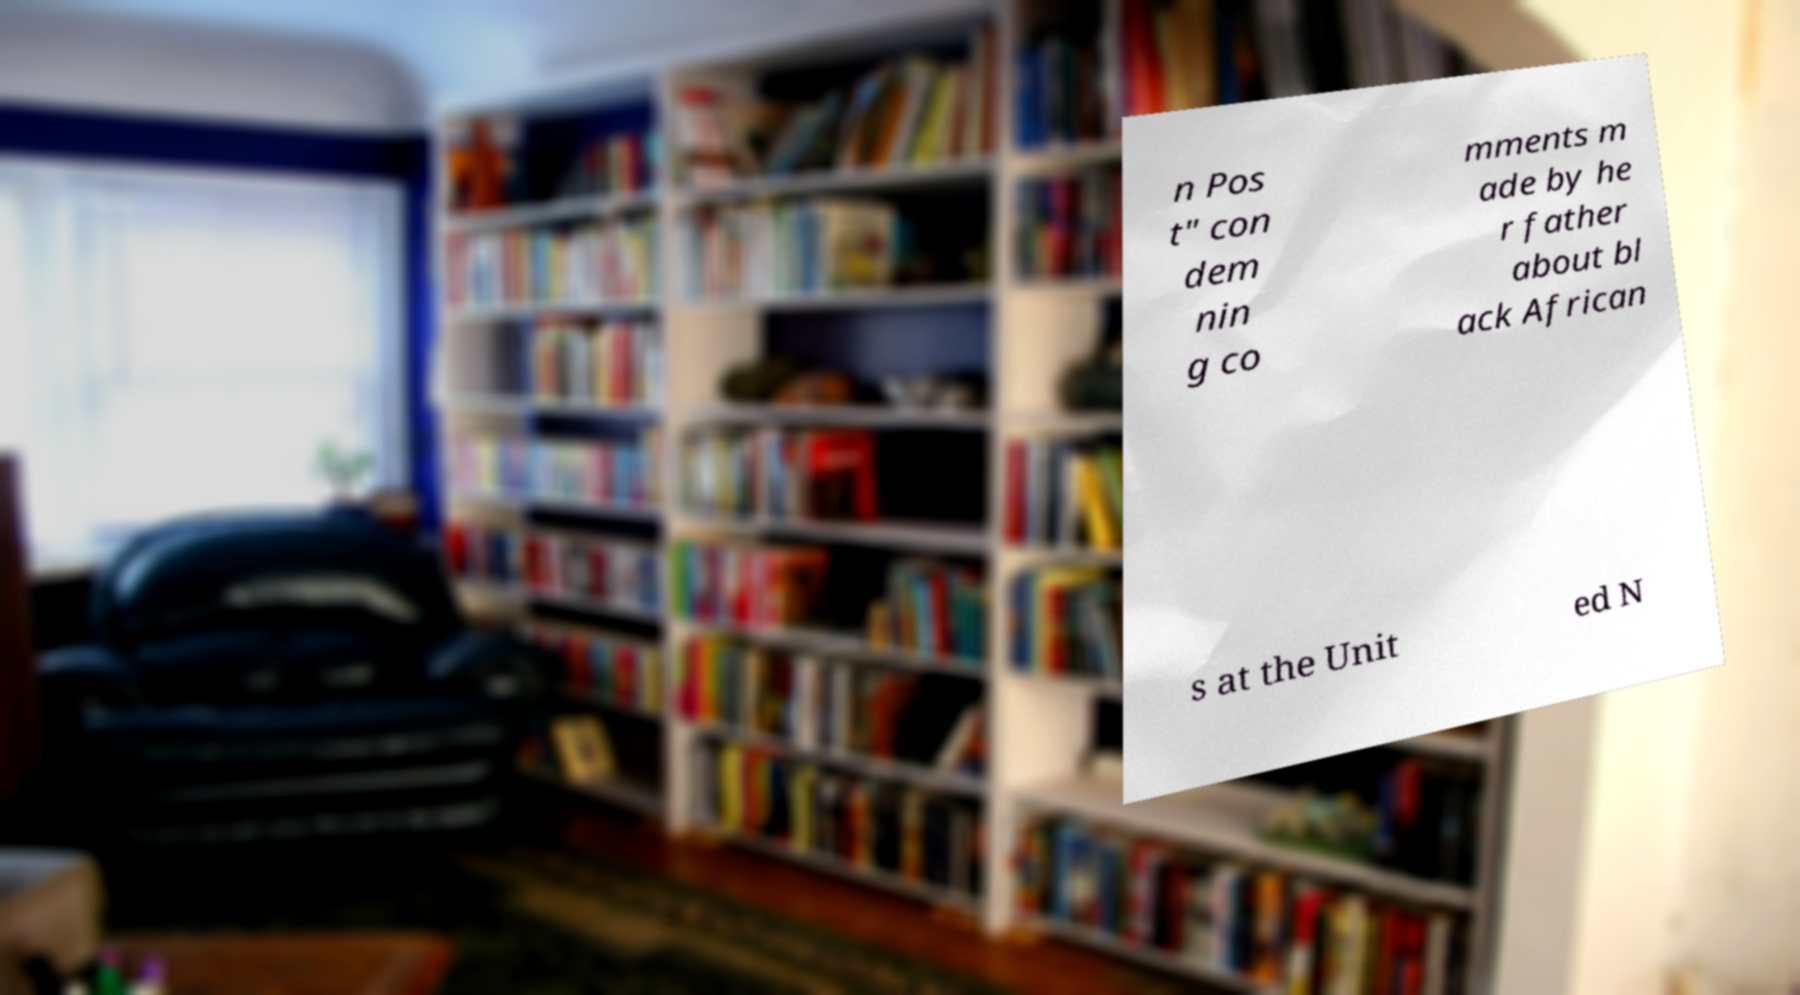I need the written content from this picture converted into text. Can you do that? n Pos t" con dem nin g co mments m ade by he r father about bl ack African s at the Unit ed N 